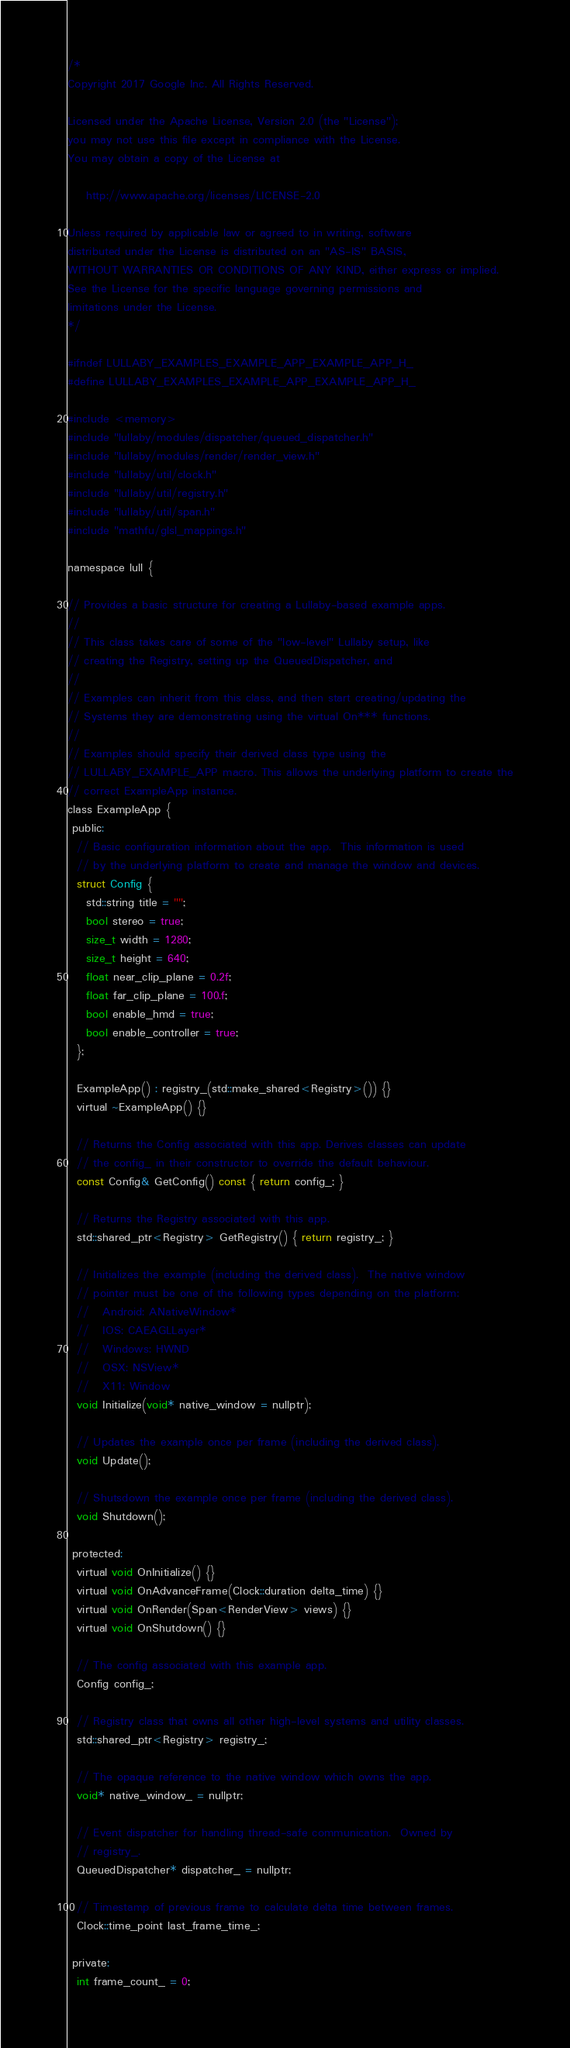<code> <loc_0><loc_0><loc_500><loc_500><_C_>/*
Copyright 2017 Google Inc. All Rights Reserved.

Licensed under the Apache License, Version 2.0 (the "License");
you may not use this file except in compliance with the License.
You may obtain a copy of the License at

    http://www.apache.org/licenses/LICENSE-2.0

Unless required by applicable law or agreed to in writing, software
distributed under the License is distributed on an "AS-IS" BASIS,
WITHOUT WARRANTIES OR CONDITIONS OF ANY KIND, either express or implied.
See the License for the specific language governing permissions and
limitations under the License.
*/

#ifndef LULLABY_EXAMPLES_EXAMPLE_APP_EXAMPLE_APP_H_
#define LULLABY_EXAMPLES_EXAMPLE_APP_EXAMPLE_APP_H_

#include <memory>
#include "lullaby/modules/dispatcher/queued_dispatcher.h"
#include "lullaby/modules/render/render_view.h"
#include "lullaby/util/clock.h"
#include "lullaby/util/registry.h"
#include "lullaby/util/span.h"
#include "mathfu/glsl_mappings.h"

namespace lull {

// Provides a basic structure for creating a Lullaby-based example apps.
//
// This class takes care of some of the "low-level" Lullaby setup, like
// creating the Registry, setting up the QueuedDispatcher, and
//
// Examples can inherit from this class, and then start creating/updating the
// Systems they are demonstrating using the virtual On*** functions.
//
// Examples should specify their derived class type using the
// LULLABY_EXAMPLE_APP macro. This allows the underlying platform to create the
// correct ExampleApp instance.
class ExampleApp {
 public:
  // Basic configuration information about the app.  This information is used
  // by the underlying platform to create and manage the window and devices.
  struct Config {
    std::string title = "";
    bool stereo = true;
    size_t width = 1280;
    size_t height = 640;
    float near_clip_plane = 0.2f;
    float far_clip_plane = 100.f;
    bool enable_hmd = true;
    bool enable_controller = true;
  };

  ExampleApp() : registry_(std::make_shared<Registry>()) {}
  virtual ~ExampleApp() {}

  // Returns the Config associated with this app. Derives classes can update
  // the config_ in their constructor to override the default behaviour.
  const Config& GetConfig() const { return config_; }

  // Returns the Registry associated with this app.
  std::shared_ptr<Registry> GetRegistry() { return registry_; }

  // Initializes the example (including the derived class).  The native window
  // pointer must be one of the following types depending on the platform:
  //   Android: ANativeWindow*
  //   IOS: CAEAGLLayer*
  //   Windows: HWND
  //   OSX: NSView*
  //   X11: Window
  void Initialize(void* native_window = nullptr);

  // Updates the example once per frame (including the derived class).
  void Update();

  // Shutsdown the example once per frame (including the derived class).
  void Shutdown();

 protected:
  virtual void OnInitialize() {}
  virtual void OnAdvanceFrame(Clock::duration delta_time) {}
  virtual void OnRender(Span<RenderView> views) {}
  virtual void OnShutdown() {}

  // The config associated with this example app.
  Config config_;

  // Registry class that owns all other high-level systems and utility classes.
  std::shared_ptr<Registry> registry_;

  // The opaque reference to the native window which owns the app.
  void* native_window_ = nullptr;

  // Event dispatcher for handling thread-safe communication.  Owned by
  // registry_.
  QueuedDispatcher* dispatcher_ = nullptr;

  // Timestamp of previous frame to calculate delta time between frames.
  Clock::time_point last_frame_time_;

 private:
  int frame_count_ = 0;
</code> 